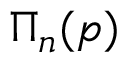<formula> <loc_0><loc_0><loc_500><loc_500>\Pi _ { n } ( p )</formula> 